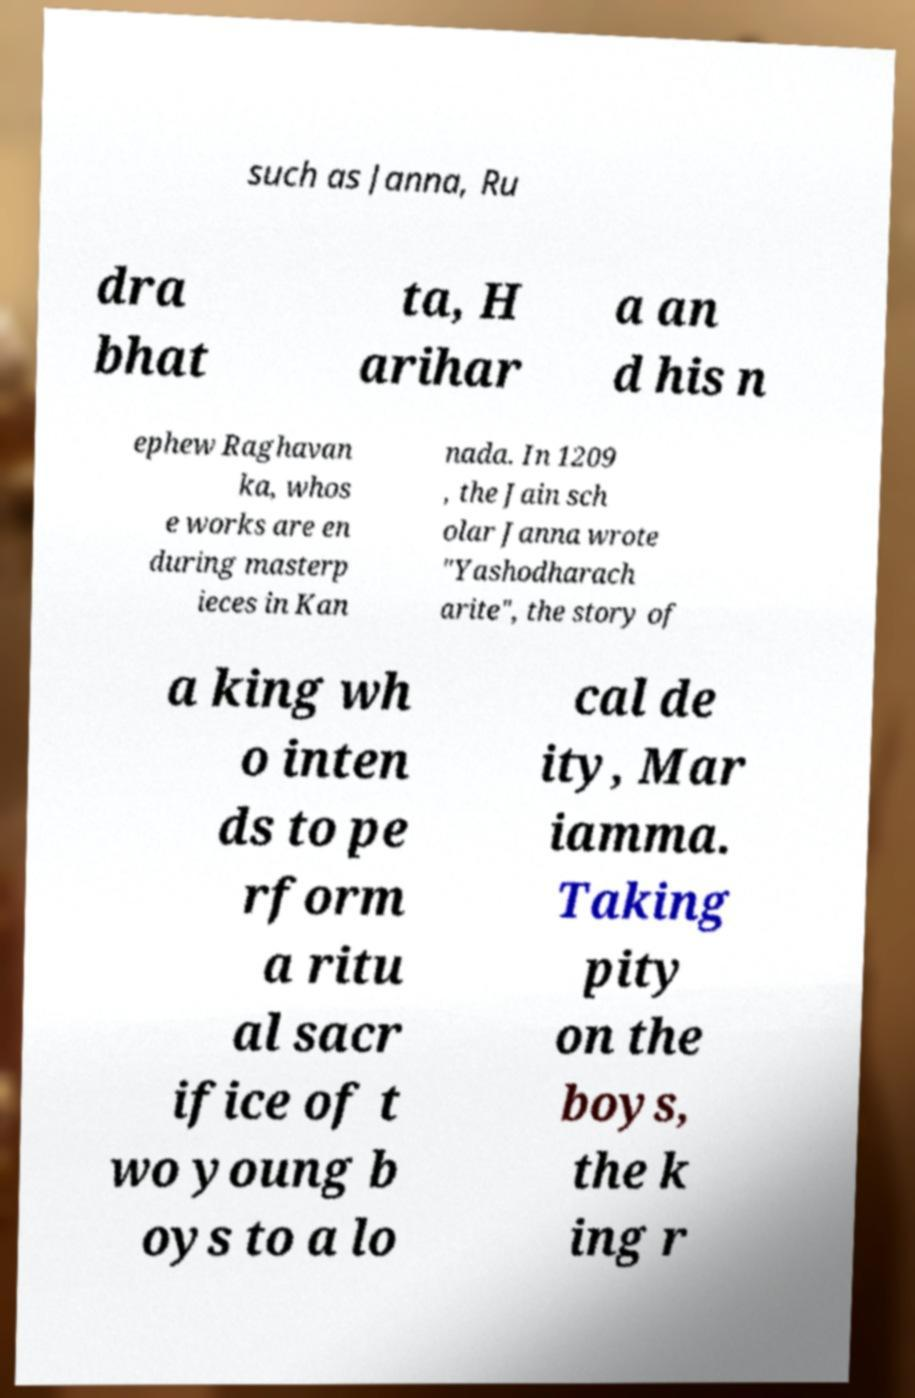Could you extract and type out the text from this image? such as Janna, Ru dra bhat ta, H arihar a an d his n ephew Raghavan ka, whos e works are en during masterp ieces in Kan nada. In 1209 , the Jain sch olar Janna wrote "Yashodharach arite", the story of a king wh o inten ds to pe rform a ritu al sacr ifice of t wo young b oys to a lo cal de ity, Mar iamma. Taking pity on the boys, the k ing r 